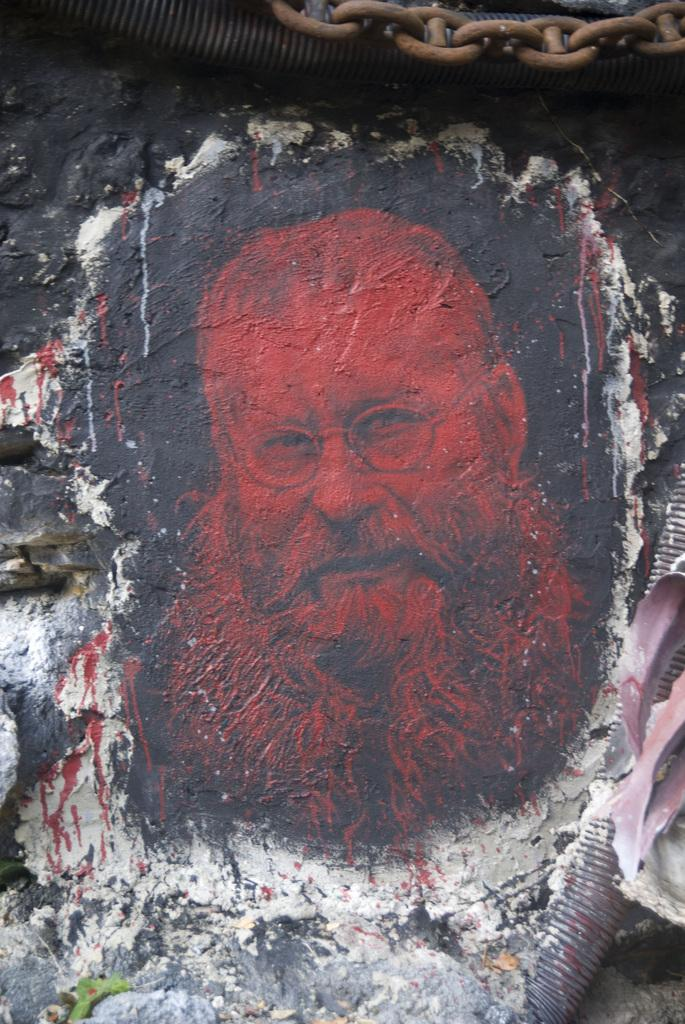What is the appearance of the man in the image? There is a man with a long beard in the image. How is the man's image presented in the image? The man's photograph is painted on the wall. What is attached to the wall above the painted photograph? There is a metal chain above the painted photograph. What type of note is the man holding in the image? There is no note present in the image; the man's photograph is painted on the wall. What does the man express towards the woman in the image? The image does not depict any interaction between the man and a woman, nor does it convey any emotions or expressions of love. 